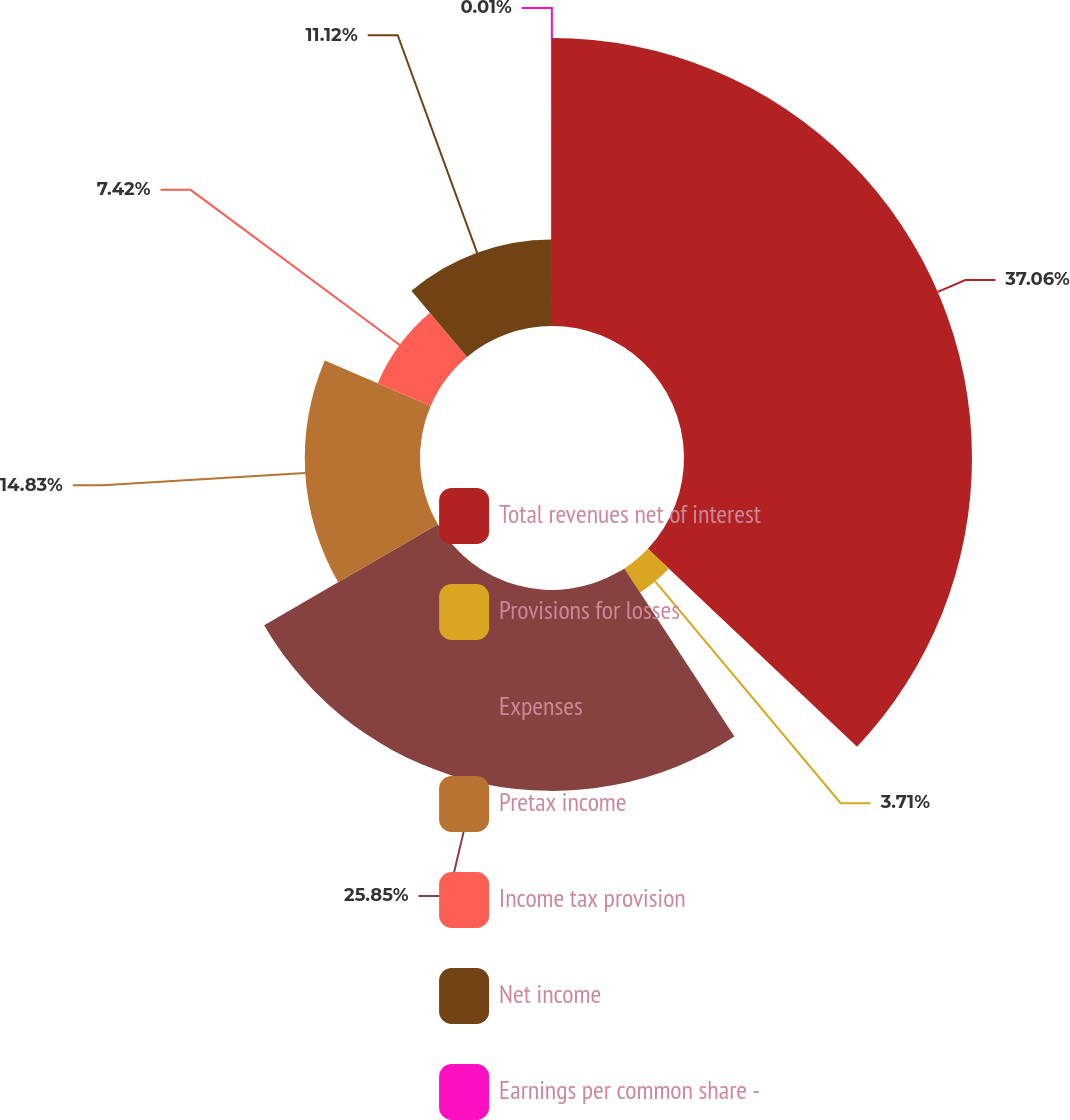<chart> <loc_0><loc_0><loc_500><loc_500><pie_chart><fcel>Total revenues net of interest<fcel>Provisions for losses<fcel>Expenses<fcel>Pretax income<fcel>Income tax provision<fcel>Net income<fcel>Earnings per common share -<nl><fcel>37.06%<fcel>3.71%<fcel>25.85%<fcel>14.83%<fcel>7.42%<fcel>11.12%<fcel>0.01%<nl></chart> 